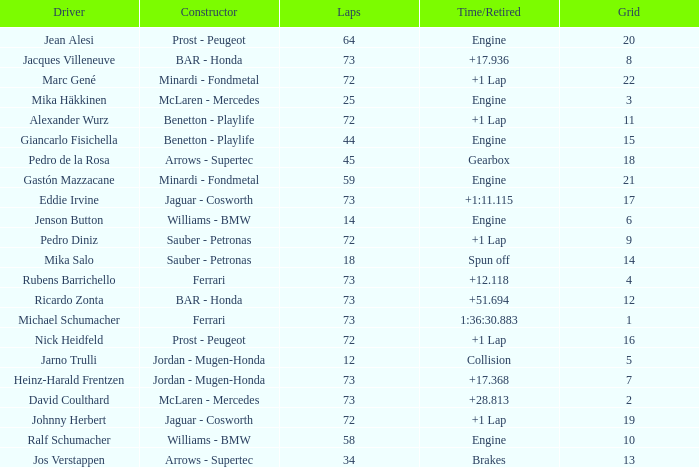How many laps did Giancarlo Fisichella do with a grid larger than 15? 0.0. Would you mind parsing the complete table? {'header': ['Driver', 'Constructor', 'Laps', 'Time/Retired', 'Grid'], 'rows': [['Jean Alesi', 'Prost - Peugeot', '64', 'Engine', '20'], ['Jacques Villeneuve', 'BAR - Honda', '73', '+17.936', '8'], ['Marc Gené', 'Minardi - Fondmetal', '72', '+1 Lap', '22'], ['Mika Häkkinen', 'McLaren - Mercedes', '25', 'Engine', '3'], ['Alexander Wurz', 'Benetton - Playlife', '72', '+1 Lap', '11'], ['Giancarlo Fisichella', 'Benetton - Playlife', '44', 'Engine', '15'], ['Pedro de la Rosa', 'Arrows - Supertec', '45', 'Gearbox', '18'], ['Gastón Mazzacane', 'Minardi - Fondmetal', '59', 'Engine', '21'], ['Eddie Irvine', 'Jaguar - Cosworth', '73', '+1:11.115', '17'], ['Jenson Button', 'Williams - BMW', '14', 'Engine', '6'], ['Pedro Diniz', 'Sauber - Petronas', '72', '+1 Lap', '9'], ['Mika Salo', 'Sauber - Petronas', '18', 'Spun off', '14'], ['Rubens Barrichello', 'Ferrari', '73', '+12.118', '4'], ['Ricardo Zonta', 'BAR - Honda', '73', '+51.694', '12'], ['Michael Schumacher', 'Ferrari', '73', '1:36:30.883', '1'], ['Nick Heidfeld', 'Prost - Peugeot', '72', '+1 Lap', '16'], ['Jarno Trulli', 'Jordan - Mugen-Honda', '12', 'Collision', '5'], ['Heinz-Harald Frentzen', 'Jordan - Mugen-Honda', '73', '+17.368', '7'], ['David Coulthard', 'McLaren - Mercedes', '73', '+28.813', '2'], ['Johnny Herbert', 'Jaguar - Cosworth', '72', '+1 Lap', '19'], ['Ralf Schumacher', 'Williams - BMW', '58', 'Engine', '10'], ['Jos Verstappen', 'Arrows - Supertec', '34', 'Brakes', '13']]} 